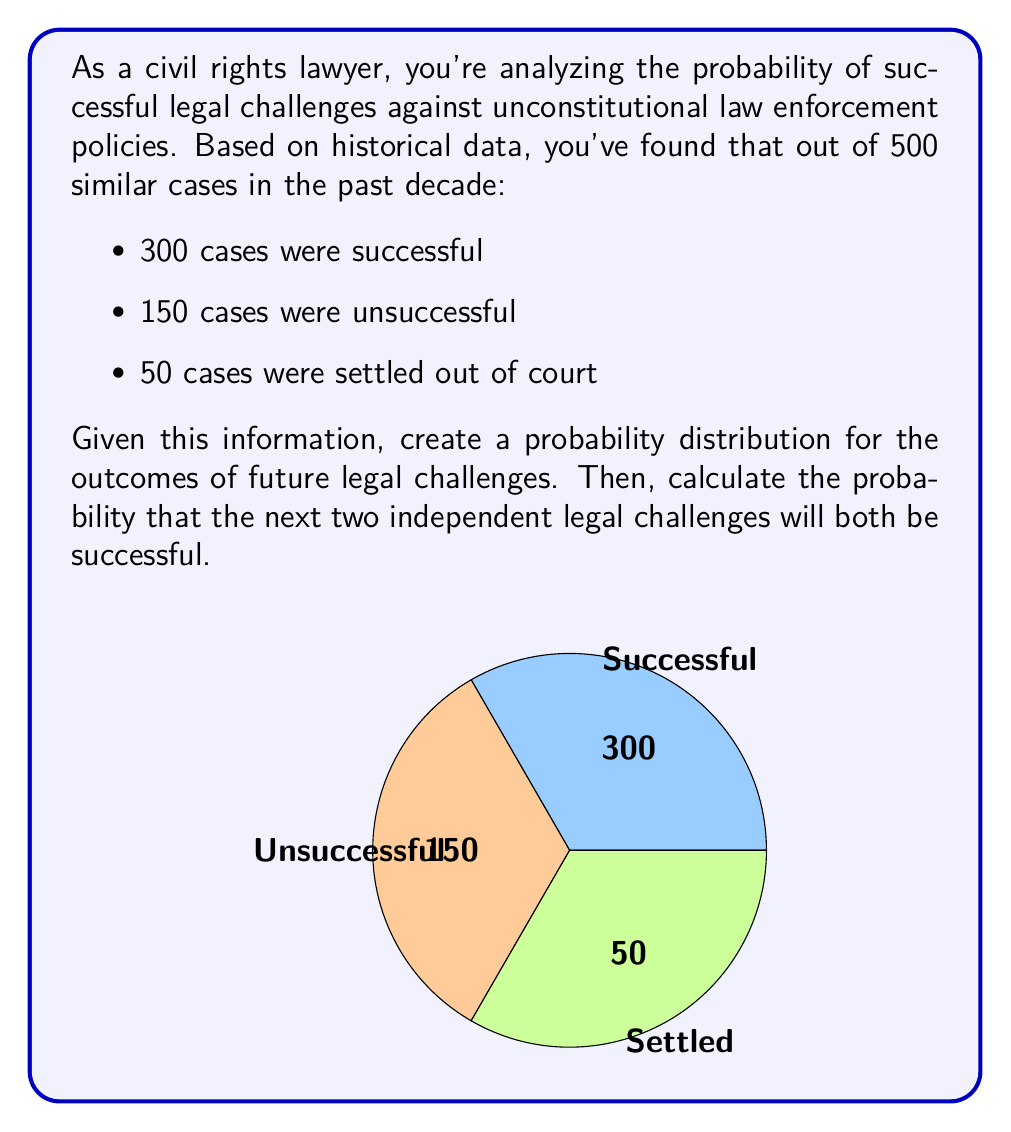Could you help me with this problem? To solve this problem, we'll follow these steps:

1. Calculate the probability of a successful legal challenge:
   $$P(\text{success}) = \frac{\text{Number of successful cases}}{\text{Total number of cases}} = \frac{300}{500} = 0.6$$

2. Create the probability distribution:
   $$P(\text{success}) = 0.6$$
   $$P(\text{unsuccessful}) = \frac{150}{500} = 0.3$$
   $$P(\text{settled}) = \frac{50}{500} = 0.1$$

3. Calculate the probability of two independent successful challenges:
   Since the events are independent, we multiply the individual probabilities:
   $$P(\text{success and success}) = P(\text{success}) \times P(\text{success}) = 0.6 \times 0.6 = 0.36$$

Therefore, the probability that the next two independent legal challenges will both be successful is 0.36 or 36%.
Answer: 0.36 